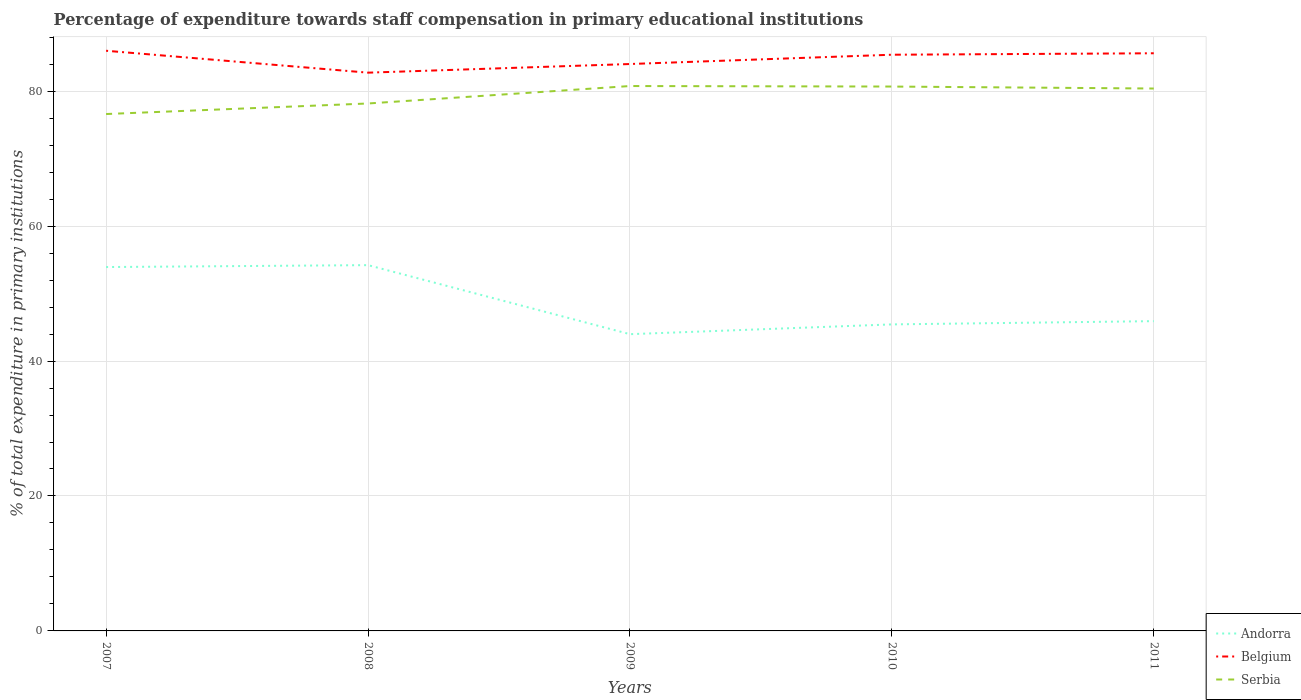How many different coloured lines are there?
Provide a short and direct response. 3. Does the line corresponding to Belgium intersect with the line corresponding to Andorra?
Give a very brief answer. No. Across all years, what is the maximum percentage of expenditure towards staff compensation in Serbia?
Provide a succinct answer. 76.61. What is the total percentage of expenditure towards staff compensation in Serbia in the graph?
Your answer should be very brief. 0.37. What is the difference between the highest and the second highest percentage of expenditure towards staff compensation in Andorra?
Your response must be concise. 10.23. Is the percentage of expenditure towards staff compensation in Andorra strictly greater than the percentage of expenditure towards staff compensation in Belgium over the years?
Provide a short and direct response. Yes. How many lines are there?
Give a very brief answer. 3. What is the difference between two consecutive major ticks on the Y-axis?
Your answer should be compact. 20. Are the values on the major ticks of Y-axis written in scientific E-notation?
Offer a very short reply. No. Does the graph contain grids?
Your answer should be very brief. Yes. Where does the legend appear in the graph?
Provide a succinct answer. Bottom right. How are the legend labels stacked?
Offer a very short reply. Vertical. What is the title of the graph?
Ensure brevity in your answer.  Percentage of expenditure towards staff compensation in primary educational institutions. Does "Philippines" appear as one of the legend labels in the graph?
Ensure brevity in your answer.  No. What is the label or title of the X-axis?
Provide a short and direct response. Years. What is the label or title of the Y-axis?
Your answer should be compact. % of total expenditure in primary institutions. What is the % of total expenditure in primary institutions of Andorra in 2007?
Keep it short and to the point. 53.93. What is the % of total expenditure in primary institutions in Belgium in 2007?
Your answer should be compact. 85.99. What is the % of total expenditure in primary institutions in Serbia in 2007?
Provide a short and direct response. 76.61. What is the % of total expenditure in primary institutions in Andorra in 2008?
Your answer should be compact. 54.22. What is the % of total expenditure in primary institutions in Belgium in 2008?
Your response must be concise. 82.74. What is the % of total expenditure in primary institutions in Serbia in 2008?
Keep it short and to the point. 78.18. What is the % of total expenditure in primary institutions of Andorra in 2009?
Provide a short and direct response. 43.98. What is the % of total expenditure in primary institutions of Belgium in 2009?
Ensure brevity in your answer.  84.03. What is the % of total expenditure in primary institutions of Serbia in 2009?
Your response must be concise. 80.76. What is the % of total expenditure in primary institutions of Andorra in 2010?
Offer a very short reply. 45.43. What is the % of total expenditure in primary institutions in Belgium in 2010?
Offer a terse response. 85.4. What is the % of total expenditure in primary institutions of Serbia in 2010?
Give a very brief answer. 80.69. What is the % of total expenditure in primary institutions of Andorra in 2011?
Ensure brevity in your answer.  45.91. What is the % of total expenditure in primary institutions in Belgium in 2011?
Provide a succinct answer. 85.62. What is the % of total expenditure in primary institutions in Serbia in 2011?
Your response must be concise. 80.39. Across all years, what is the maximum % of total expenditure in primary institutions of Andorra?
Provide a short and direct response. 54.22. Across all years, what is the maximum % of total expenditure in primary institutions of Belgium?
Make the answer very short. 85.99. Across all years, what is the maximum % of total expenditure in primary institutions of Serbia?
Your answer should be compact. 80.76. Across all years, what is the minimum % of total expenditure in primary institutions in Andorra?
Your answer should be very brief. 43.98. Across all years, what is the minimum % of total expenditure in primary institutions in Belgium?
Offer a terse response. 82.74. Across all years, what is the minimum % of total expenditure in primary institutions in Serbia?
Your response must be concise. 76.61. What is the total % of total expenditure in primary institutions in Andorra in the graph?
Your response must be concise. 243.48. What is the total % of total expenditure in primary institutions in Belgium in the graph?
Ensure brevity in your answer.  423.78. What is the total % of total expenditure in primary institutions in Serbia in the graph?
Make the answer very short. 396.63. What is the difference between the % of total expenditure in primary institutions of Andorra in 2007 and that in 2008?
Keep it short and to the point. -0.28. What is the difference between the % of total expenditure in primary institutions in Belgium in 2007 and that in 2008?
Offer a terse response. 3.25. What is the difference between the % of total expenditure in primary institutions of Serbia in 2007 and that in 2008?
Your response must be concise. -1.56. What is the difference between the % of total expenditure in primary institutions in Andorra in 2007 and that in 2009?
Ensure brevity in your answer.  9.95. What is the difference between the % of total expenditure in primary institutions in Belgium in 2007 and that in 2009?
Offer a terse response. 1.97. What is the difference between the % of total expenditure in primary institutions in Serbia in 2007 and that in 2009?
Provide a succinct answer. -4.15. What is the difference between the % of total expenditure in primary institutions in Andorra in 2007 and that in 2010?
Your response must be concise. 8.5. What is the difference between the % of total expenditure in primary institutions in Belgium in 2007 and that in 2010?
Keep it short and to the point. 0.59. What is the difference between the % of total expenditure in primary institutions in Serbia in 2007 and that in 2010?
Ensure brevity in your answer.  -4.07. What is the difference between the % of total expenditure in primary institutions in Andorra in 2007 and that in 2011?
Offer a terse response. 8.02. What is the difference between the % of total expenditure in primary institutions in Belgium in 2007 and that in 2011?
Ensure brevity in your answer.  0.37. What is the difference between the % of total expenditure in primary institutions in Serbia in 2007 and that in 2011?
Offer a terse response. -3.78. What is the difference between the % of total expenditure in primary institutions of Andorra in 2008 and that in 2009?
Keep it short and to the point. 10.23. What is the difference between the % of total expenditure in primary institutions in Belgium in 2008 and that in 2009?
Give a very brief answer. -1.28. What is the difference between the % of total expenditure in primary institutions of Serbia in 2008 and that in 2009?
Give a very brief answer. -2.59. What is the difference between the % of total expenditure in primary institutions of Andorra in 2008 and that in 2010?
Offer a terse response. 8.78. What is the difference between the % of total expenditure in primary institutions in Belgium in 2008 and that in 2010?
Offer a terse response. -2.66. What is the difference between the % of total expenditure in primary institutions of Serbia in 2008 and that in 2010?
Your answer should be very brief. -2.51. What is the difference between the % of total expenditure in primary institutions in Andorra in 2008 and that in 2011?
Your answer should be very brief. 8.3. What is the difference between the % of total expenditure in primary institutions of Belgium in 2008 and that in 2011?
Make the answer very short. -2.87. What is the difference between the % of total expenditure in primary institutions in Serbia in 2008 and that in 2011?
Offer a very short reply. -2.22. What is the difference between the % of total expenditure in primary institutions in Andorra in 2009 and that in 2010?
Keep it short and to the point. -1.45. What is the difference between the % of total expenditure in primary institutions of Belgium in 2009 and that in 2010?
Give a very brief answer. -1.38. What is the difference between the % of total expenditure in primary institutions of Serbia in 2009 and that in 2010?
Provide a short and direct response. 0.08. What is the difference between the % of total expenditure in primary institutions of Andorra in 2009 and that in 2011?
Your answer should be very brief. -1.93. What is the difference between the % of total expenditure in primary institutions of Belgium in 2009 and that in 2011?
Your answer should be very brief. -1.59. What is the difference between the % of total expenditure in primary institutions of Serbia in 2009 and that in 2011?
Your answer should be very brief. 0.37. What is the difference between the % of total expenditure in primary institutions of Andorra in 2010 and that in 2011?
Give a very brief answer. -0.48. What is the difference between the % of total expenditure in primary institutions in Belgium in 2010 and that in 2011?
Your answer should be very brief. -0.22. What is the difference between the % of total expenditure in primary institutions of Serbia in 2010 and that in 2011?
Your answer should be compact. 0.29. What is the difference between the % of total expenditure in primary institutions in Andorra in 2007 and the % of total expenditure in primary institutions in Belgium in 2008?
Provide a succinct answer. -28.81. What is the difference between the % of total expenditure in primary institutions of Andorra in 2007 and the % of total expenditure in primary institutions of Serbia in 2008?
Provide a succinct answer. -24.24. What is the difference between the % of total expenditure in primary institutions of Belgium in 2007 and the % of total expenditure in primary institutions of Serbia in 2008?
Offer a very short reply. 7.82. What is the difference between the % of total expenditure in primary institutions in Andorra in 2007 and the % of total expenditure in primary institutions in Belgium in 2009?
Offer a very short reply. -30.09. What is the difference between the % of total expenditure in primary institutions in Andorra in 2007 and the % of total expenditure in primary institutions in Serbia in 2009?
Your answer should be compact. -26.83. What is the difference between the % of total expenditure in primary institutions of Belgium in 2007 and the % of total expenditure in primary institutions of Serbia in 2009?
Your answer should be very brief. 5.23. What is the difference between the % of total expenditure in primary institutions of Andorra in 2007 and the % of total expenditure in primary institutions of Belgium in 2010?
Give a very brief answer. -31.47. What is the difference between the % of total expenditure in primary institutions of Andorra in 2007 and the % of total expenditure in primary institutions of Serbia in 2010?
Your answer should be very brief. -26.75. What is the difference between the % of total expenditure in primary institutions of Belgium in 2007 and the % of total expenditure in primary institutions of Serbia in 2010?
Your response must be concise. 5.31. What is the difference between the % of total expenditure in primary institutions of Andorra in 2007 and the % of total expenditure in primary institutions of Belgium in 2011?
Keep it short and to the point. -31.69. What is the difference between the % of total expenditure in primary institutions of Andorra in 2007 and the % of total expenditure in primary institutions of Serbia in 2011?
Keep it short and to the point. -26.46. What is the difference between the % of total expenditure in primary institutions of Belgium in 2007 and the % of total expenditure in primary institutions of Serbia in 2011?
Offer a terse response. 5.6. What is the difference between the % of total expenditure in primary institutions of Andorra in 2008 and the % of total expenditure in primary institutions of Belgium in 2009?
Provide a short and direct response. -29.81. What is the difference between the % of total expenditure in primary institutions in Andorra in 2008 and the % of total expenditure in primary institutions in Serbia in 2009?
Keep it short and to the point. -26.55. What is the difference between the % of total expenditure in primary institutions in Belgium in 2008 and the % of total expenditure in primary institutions in Serbia in 2009?
Your answer should be compact. 1.98. What is the difference between the % of total expenditure in primary institutions of Andorra in 2008 and the % of total expenditure in primary institutions of Belgium in 2010?
Offer a very short reply. -31.19. What is the difference between the % of total expenditure in primary institutions of Andorra in 2008 and the % of total expenditure in primary institutions of Serbia in 2010?
Keep it short and to the point. -26.47. What is the difference between the % of total expenditure in primary institutions of Belgium in 2008 and the % of total expenditure in primary institutions of Serbia in 2010?
Offer a terse response. 2.06. What is the difference between the % of total expenditure in primary institutions in Andorra in 2008 and the % of total expenditure in primary institutions in Belgium in 2011?
Your answer should be compact. -31.4. What is the difference between the % of total expenditure in primary institutions in Andorra in 2008 and the % of total expenditure in primary institutions in Serbia in 2011?
Ensure brevity in your answer.  -26.18. What is the difference between the % of total expenditure in primary institutions of Belgium in 2008 and the % of total expenditure in primary institutions of Serbia in 2011?
Provide a succinct answer. 2.35. What is the difference between the % of total expenditure in primary institutions of Andorra in 2009 and the % of total expenditure in primary institutions of Belgium in 2010?
Your answer should be very brief. -41.42. What is the difference between the % of total expenditure in primary institutions in Andorra in 2009 and the % of total expenditure in primary institutions in Serbia in 2010?
Offer a very short reply. -36.7. What is the difference between the % of total expenditure in primary institutions in Belgium in 2009 and the % of total expenditure in primary institutions in Serbia in 2010?
Ensure brevity in your answer.  3.34. What is the difference between the % of total expenditure in primary institutions of Andorra in 2009 and the % of total expenditure in primary institutions of Belgium in 2011?
Your answer should be very brief. -41.63. What is the difference between the % of total expenditure in primary institutions in Andorra in 2009 and the % of total expenditure in primary institutions in Serbia in 2011?
Provide a short and direct response. -36.41. What is the difference between the % of total expenditure in primary institutions in Belgium in 2009 and the % of total expenditure in primary institutions in Serbia in 2011?
Your response must be concise. 3.63. What is the difference between the % of total expenditure in primary institutions of Andorra in 2010 and the % of total expenditure in primary institutions of Belgium in 2011?
Provide a short and direct response. -40.19. What is the difference between the % of total expenditure in primary institutions in Andorra in 2010 and the % of total expenditure in primary institutions in Serbia in 2011?
Your response must be concise. -34.96. What is the difference between the % of total expenditure in primary institutions of Belgium in 2010 and the % of total expenditure in primary institutions of Serbia in 2011?
Provide a short and direct response. 5.01. What is the average % of total expenditure in primary institutions in Andorra per year?
Provide a short and direct response. 48.7. What is the average % of total expenditure in primary institutions in Belgium per year?
Offer a very short reply. 84.76. What is the average % of total expenditure in primary institutions in Serbia per year?
Offer a very short reply. 79.33. In the year 2007, what is the difference between the % of total expenditure in primary institutions of Andorra and % of total expenditure in primary institutions of Belgium?
Provide a short and direct response. -32.06. In the year 2007, what is the difference between the % of total expenditure in primary institutions in Andorra and % of total expenditure in primary institutions in Serbia?
Give a very brief answer. -22.68. In the year 2007, what is the difference between the % of total expenditure in primary institutions of Belgium and % of total expenditure in primary institutions of Serbia?
Your answer should be compact. 9.38. In the year 2008, what is the difference between the % of total expenditure in primary institutions of Andorra and % of total expenditure in primary institutions of Belgium?
Keep it short and to the point. -28.53. In the year 2008, what is the difference between the % of total expenditure in primary institutions of Andorra and % of total expenditure in primary institutions of Serbia?
Provide a succinct answer. -23.96. In the year 2008, what is the difference between the % of total expenditure in primary institutions of Belgium and % of total expenditure in primary institutions of Serbia?
Your response must be concise. 4.57. In the year 2009, what is the difference between the % of total expenditure in primary institutions of Andorra and % of total expenditure in primary institutions of Belgium?
Offer a very short reply. -40.04. In the year 2009, what is the difference between the % of total expenditure in primary institutions in Andorra and % of total expenditure in primary institutions in Serbia?
Keep it short and to the point. -36.78. In the year 2009, what is the difference between the % of total expenditure in primary institutions in Belgium and % of total expenditure in primary institutions in Serbia?
Your answer should be compact. 3.26. In the year 2010, what is the difference between the % of total expenditure in primary institutions in Andorra and % of total expenditure in primary institutions in Belgium?
Your response must be concise. -39.97. In the year 2010, what is the difference between the % of total expenditure in primary institutions of Andorra and % of total expenditure in primary institutions of Serbia?
Offer a terse response. -35.25. In the year 2010, what is the difference between the % of total expenditure in primary institutions of Belgium and % of total expenditure in primary institutions of Serbia?
Your response must be concise. 4.72. In the year 2011, what is the difference between the % of total expenditure in primary institutions of Andorra and % of total expenditure in primary institutions of Belgium?
Provide a succinct answer. -39.7. In the year 2011, what is the difference between the % of total expenditure in primary institutions of Andorra and % of total expenditure in primary institutions of Serbia?
Give a very brief answer. -34.48. In the year 2011, what is the difference between the % of total expenditure in primary institutions in Belgium and % of total expenditure in primary institutions in Serbia?
Provide a succinct answer. 5.23. What is the ratio of the % of total expenditure in primary institutions of Belgium in 2007 to that in 2008?
Make the answer very short. 1.04. What is the ratio of the % of total expenditure in primary institutions of Serbia in 2007 to that in 2008?
Make the answer very short. 0.98. What is the ratio of the % of total expenditure in primary institutions of Andorra in 2007 to that in 2009?
Provide a succinct answer. 1.23. What is the ratio of the % of total expenditure in primary institutions in Belgium in 2007 to that in 2009?
Ensure brevity in your answer.  1.02. What is the ratio of the % of total expenditure in primary institutions of Serbia in 2007 to that in 2009?
Ensure brevity in your answer.  0.95. What is the ratio of the % of total expenditure in primary institutions in Andorra in 2007 to that in 2010?
Your answer should be very brief. 1.19. What is the ratio of the % of total expenditure in primary institutions in Belgium in 2007 to that in 2010?
Your answer should be compact. 1.01. What is the ratio of the % of total expenditure in primary institutions of Serbia in 2007 to that in 2010?
Make the answer very short. 0.95. What is the ratio of the % of total expenditure in primary institutions of Andorra in 2007 to that in 2011?
Make the answer very short. 1.17. What is the ratio of the % of total expenditure in primary institutions of Belgium in 2007 to that in 2011?
Provide a short and direct response. 1. What is the ratio of the % of total expenditure in primary institutions of Serbia in 2007 to that in 2011?
Your answer should be very brief. 0.95. What is the ratio of the % of total expenditure in primary institutions of Andorra in 2008 to that in 2009?
Offer a terse response. 1.23. What is the ratio of the % of total expenditure in primary institutions in Belgium in 2008 to that in 2009?
Keep it short and to the point. 0.98. What is the ratio of the % of total expenditure in primary institutions in Andorra in 2008 to that in 2010?
Keep it short and to the point. 1.19. What is the ratio of the % of total expenditure in primary institutions of Belgium in 2008 to that in 2010?
Provide a succinct answer. 0.97. What is the ratio of the % of total expenditure in primary institutions of Serbia in 2008 to that in 2010?
Offer a very short reply. 0.97. What is the ratio of the % of total expenditure in primary institutions of Andorra in 2008 to that in 2011?
Offer a very short reply. 1.18. What is the ratio of the % of total expenditure in primary institutions of Belgium in 2008 to that in 2011?
Keep it short and to the point. 0.97. What is the ratio of the % of total expenditure in primary institutions in Serbia in 2008 to that in 2011?
Provide a succinct answer. 0.97. What is the ratio of the % of total expenditure in primary institutions in Andorra in 2009 to that in 2010?
Provide a short and direct response. 0.97. What is the ratio of the % of total expenditure in primary institutions of Belgium in 2009 to that in 2010?
Your response must be concise. 0.98. What is the ratio of the % of total expenditure in primary institutions in Andorra in 2009 to that in 2011?
Offer a terse response. 0.96. What is the ratio of the % of total expenditure in primary institutions of Belgium in 2009 to that in 2011?
Provide a succinct answer. 0.98. What is the ratio of the % of total expenditure in primary institutions of Serbia in 2009 to that in 2011?
Provide a short and direct response. 1. What is the ratio of the % of total expenditure in primary institutions of Serbia in 2010 to that in 2011?
Your answer should be compact. 1. What is the difference between the highest and the second highest % of total expenditure in primary institutions of Andorra?
Offer a very short reply. 0.28. What is the difference between the highest and the second highest % of total expenditure in primary institutions in Belgium?
Provide a short and direct response. 0.37. What is the difference between the highest and the second highest % of total expenditure in primary institutions in Serbia?
Your answer should be very brief. 0.08. What is the difference between the highest and the lowest % of total expenditure in primary institutions of Andorra?
Make the answer very short. 10.23. What is the difference between the highest and the lowest % of total expenditure in primary institutions in Belgium?
Your response must be concise. 3.25. What is the difference between the highest and the lowest % of total expenditure in primary institutions in Serbia?
Give a very brief answer. 4.15. 